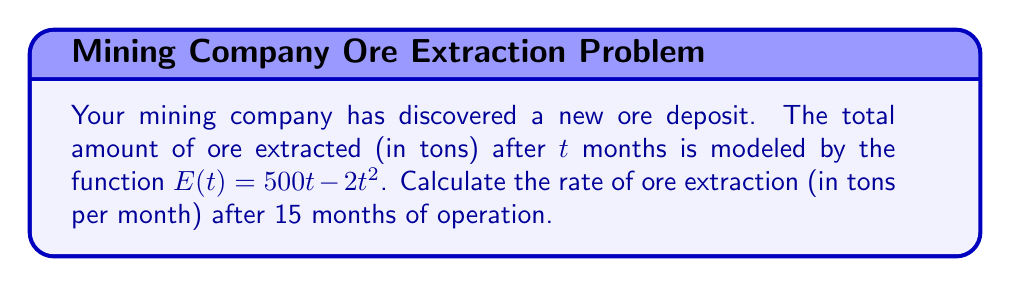Give your solution to this math problem. To solve this problem, we need to follow these steps:

1) The rate of extraction is the derivative of the total amount extracted with respect to time.

2) Given: $E(t) = 500t - 2t^2$

3) To find the rate of extraction, we need to calculate $E'(t)$:
   
   $$E'(t) = \frac{d}{dt}(500t - 2t^2) = 500 - 4t$$

4) This gives us the general formula for the rate of extraction at any time $t$.

5) To find the rate after 15 months, we substitute $t = 15$ into our derivative:

   $$E'(15) = 500 - 4(15) = 500 - 60 = 440$$

Therefore, after 15 months, the rate of ore extraction is 440 tons per month.
Answer: 440 tons/month 